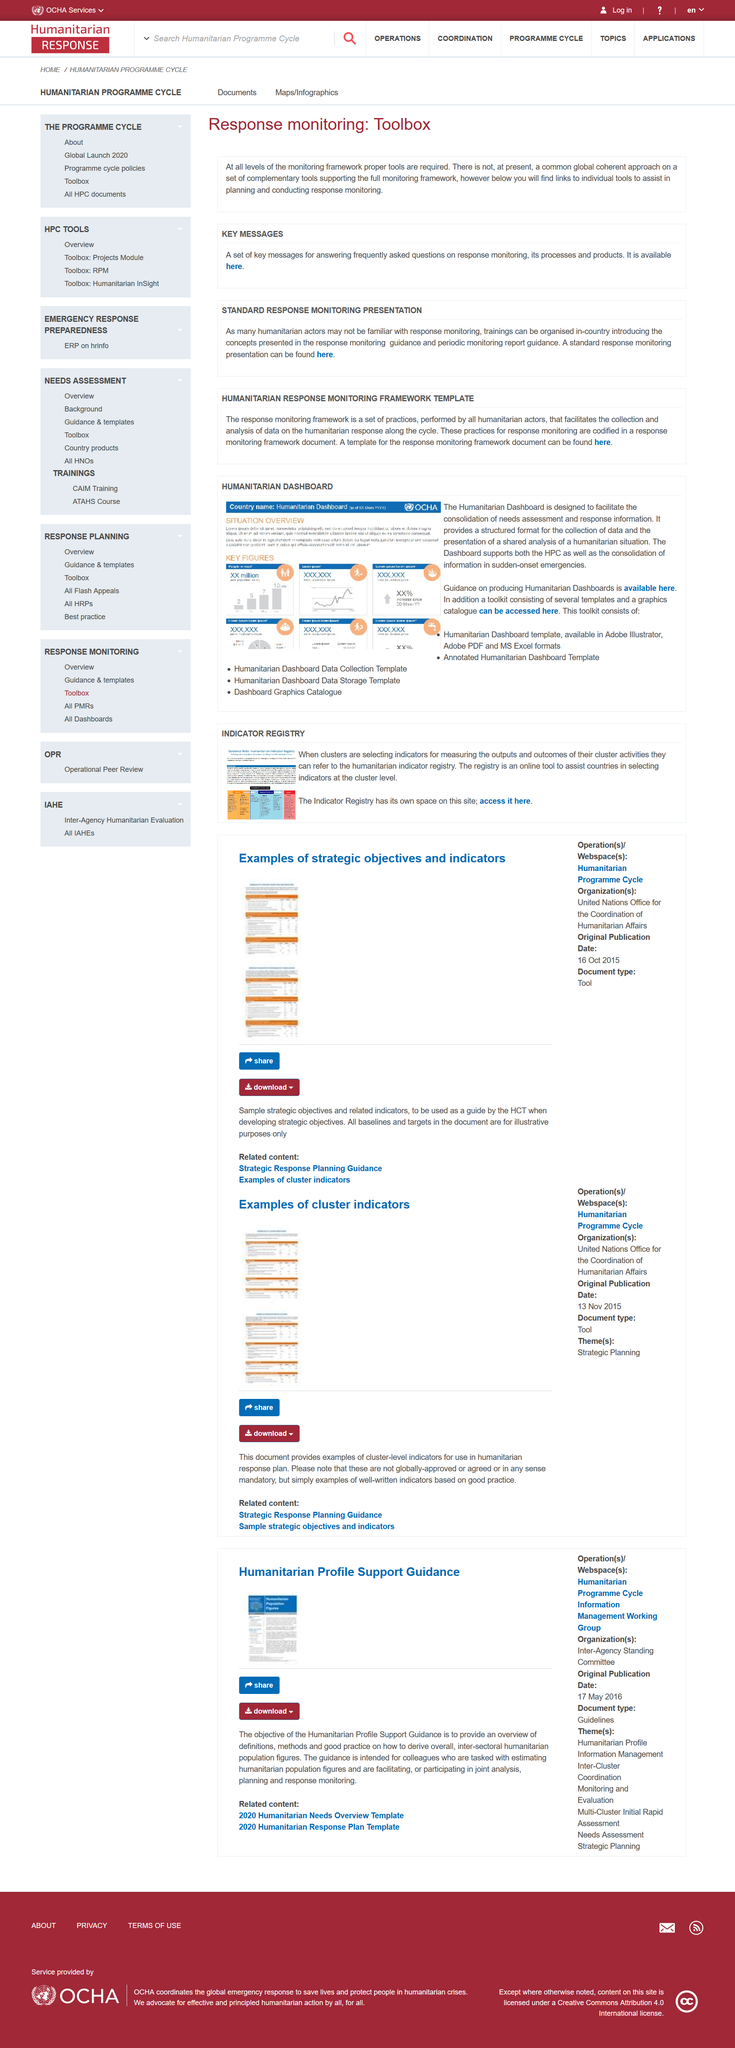Point out several critical features in this image. The humanitarian dashboard supports the Humanitarian Policy and Coordination (HPC) agenda and consolidates information in sudden-onset emergencies. The Response Monitoring Toolbox includes a Standard Response Monitoring Presentation. The Humanitarian dashboard is intended to streamline the process of collecting and analyzing information about humanitarian needs and responses. The toolkit includes a Humanitarian Dashboard template available in Adobe Illustrator, Adobe PDF, and MS Excel formats, and an Annotated Humanitarian Dashboard template. Yes, the set of key messages is useful in answering frequently asked questions on response monitoring. 